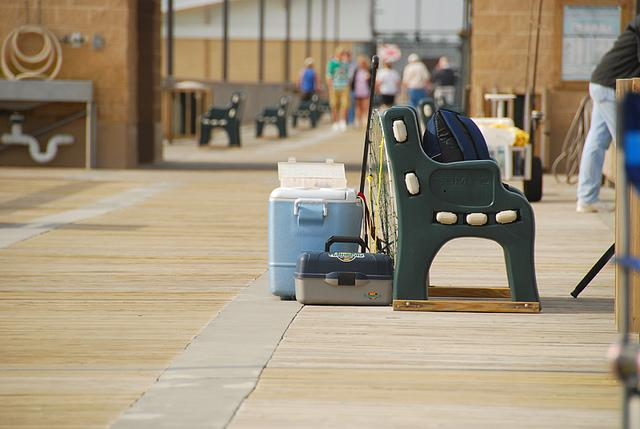What will the person who left this gear do with it? fishing 